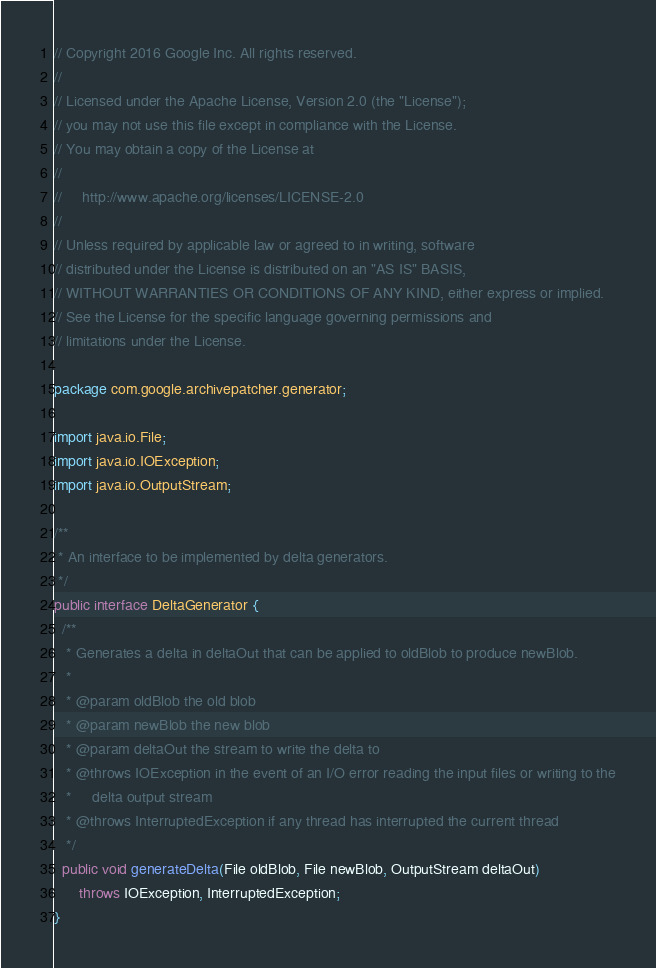Convert code to text. <code><loc_0><loc_0><loc_500><loc_500><_Java_>// Copyright 2016 Google Inc. All rights reserved.
//
// Licensed under the Apache License, Version 2.0 (the "License");
// you may not use this file except in compliance with the License.
// You may obtain a copy of the License at
//
//     http://www.apache.org/licenses/LICENSE-2.0
//
// Unless required by applicable law or agreed to in writing, software
// distributed under the License is distributed on an "AS IS" BASIS,
// WITHOUT WARRANTIES OR CONDITIONS OF ANY KIND, either express or implied.
// See the License for the specific language governing permissions and
// limitations under the License.

package com.google.archivepatcher.generator;

import java.io.File;
import java.io.IOException;
import java.io.OutputStream;

/**
 * An interface to be implemented by delta generators.
 */
public interface DeltaGenerator {
  /**
   * Generates a delta in deltaOut that can be applied to oldBlob to produce newBlob.
   *
   * @param oldBlob the old blob
   * @param newBlob the new blob
   * @param deltaOut the stream to write the delta to
   * @throws IOException in the event of an I/O error reading the input files or writing to the
   *     delta output stream
   * @throws InterruptedException if any thread has interrupted the current thread
   */
  public void generateDelta(File oldBlob, File newBlob, OutputStream deltaOut)
      throws IOException, InterruptedException;
}
</code> 